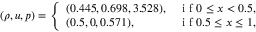<formula> <loc_0><loc_0><loc_500><loc_500>\left ( \rho , u , p \right ) = \left \{ \begin{array} { l l } { ( 0 . 4 4 5 , 0 . 6 9 8 , 3 . 5 2 8 ) , } & { i f 0 \leq x < 0 . 5 , } \\ { ( 0 . 5 , 0 , 0 . 5 7 1 ) , } & { i f 0 . 5 \leq x \leq 1 , } \end{array}</formula> 